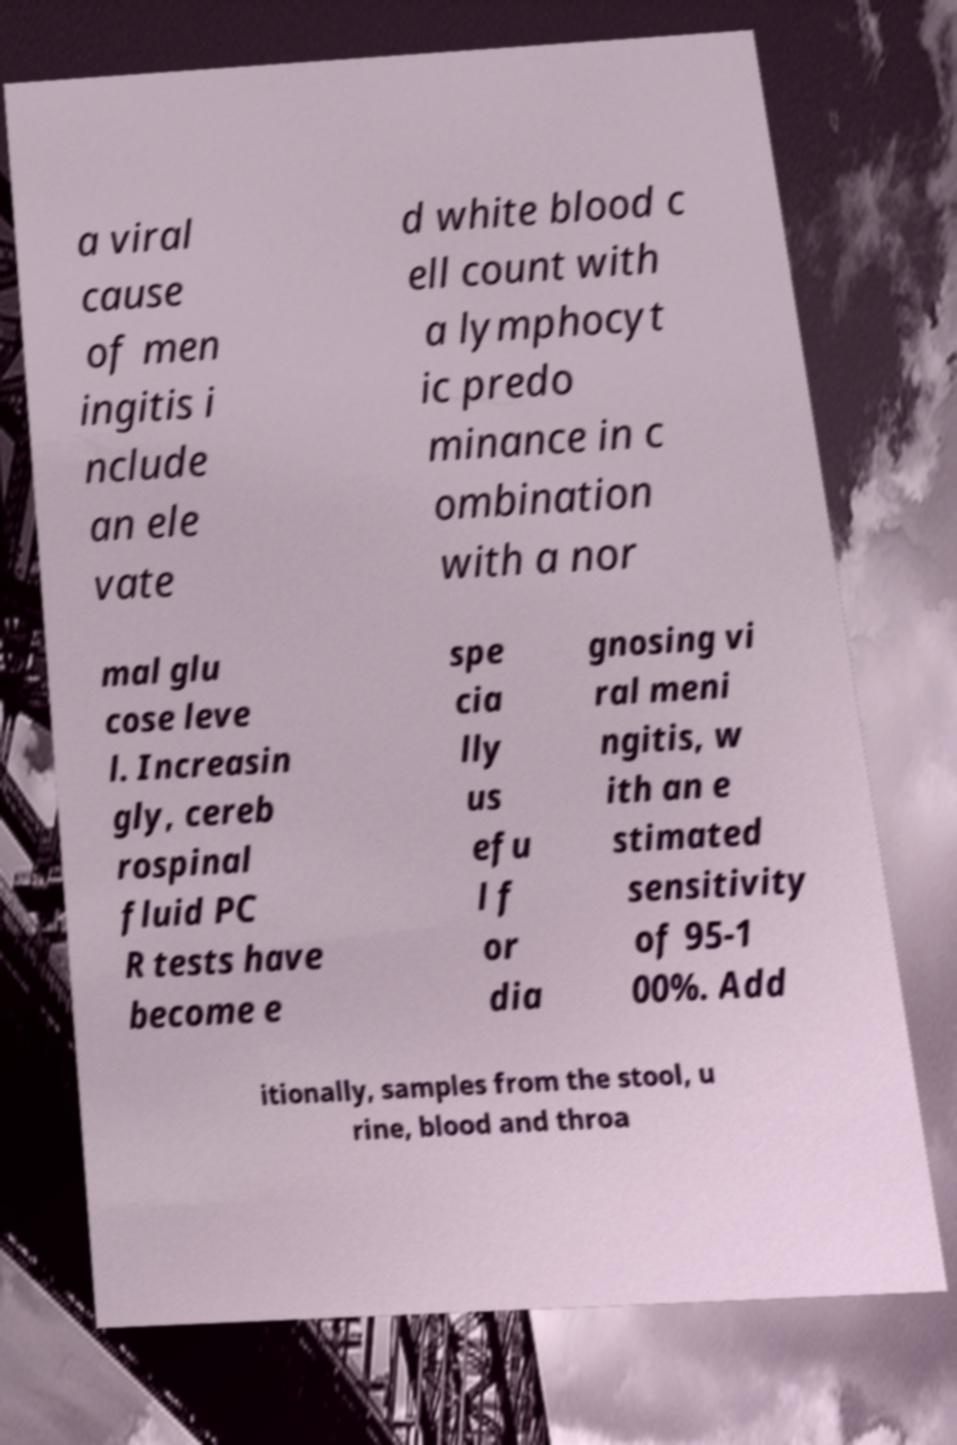What messages or text are displayed in this image? I need them in a readable, typed format. a viral cause of men ingitis i nclude an ele vate d white blood c ell count with a lymphocyt ic predo minance in c ombination with a nor mal glu cose leve l. Increasin gly, cereb rospinal fluid PC R tests have become e spe cia lly us efu l f or dia gnosing vi ral meni ngitis, w ith an e stimated sensitivity of 95-1 00%. Add itionally, samples from the stool, u rine, blood and throa 